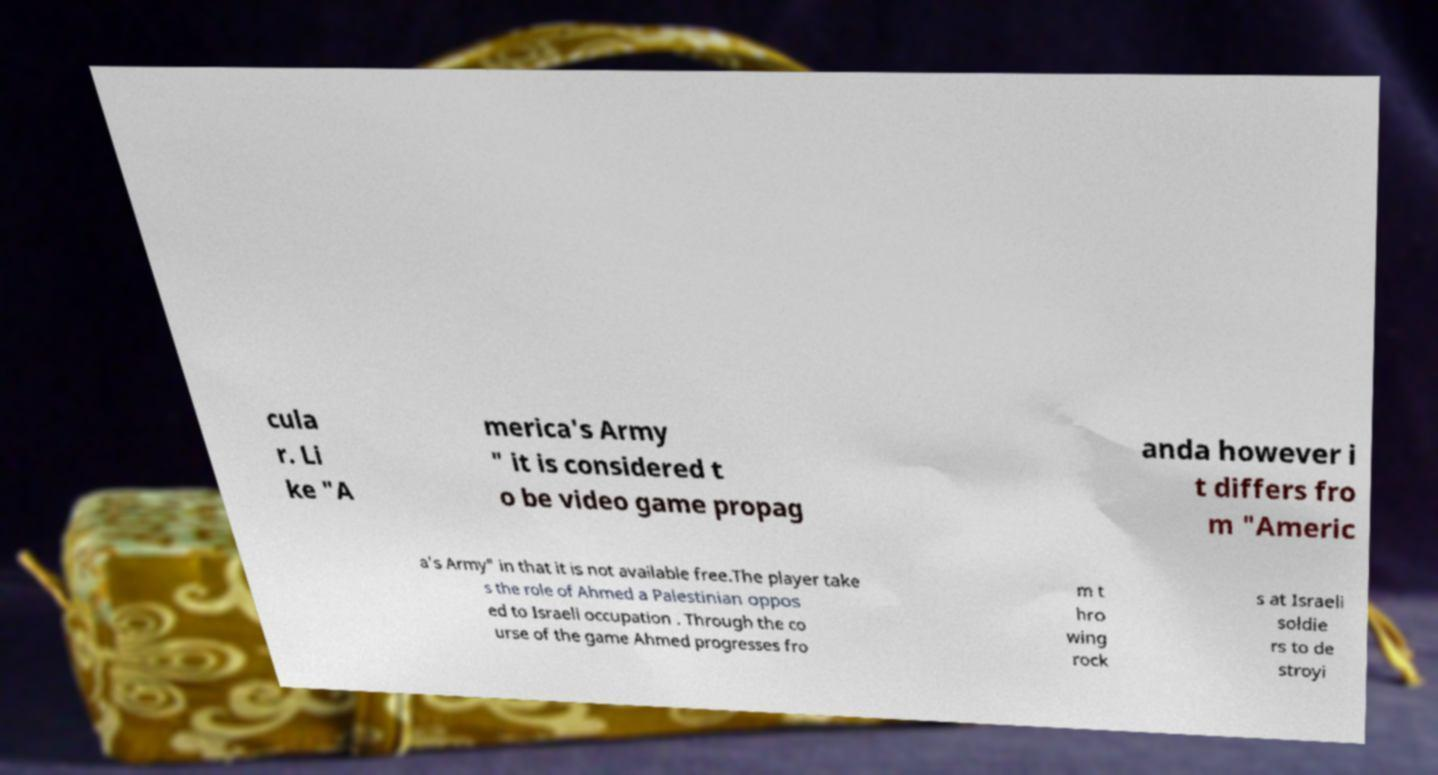Can you accurately transcribe the text from the provided image for me? cula r. Li ke "A merica's Army " it is considered t o be video game propag anda however i t differs fro m "Americ a's Army" in that it is not available free.The player take s the role of Ahmed a Palestinian oppos ed to Israeli occupation . Through the co urse of the game Ahmed progresses fro m t hro wing rock s at Israeli soldie rs to de stroyi 